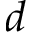Convert formula to latex. <formula><loc_0><loc_0><loc_500><loc_500>d</formula> 